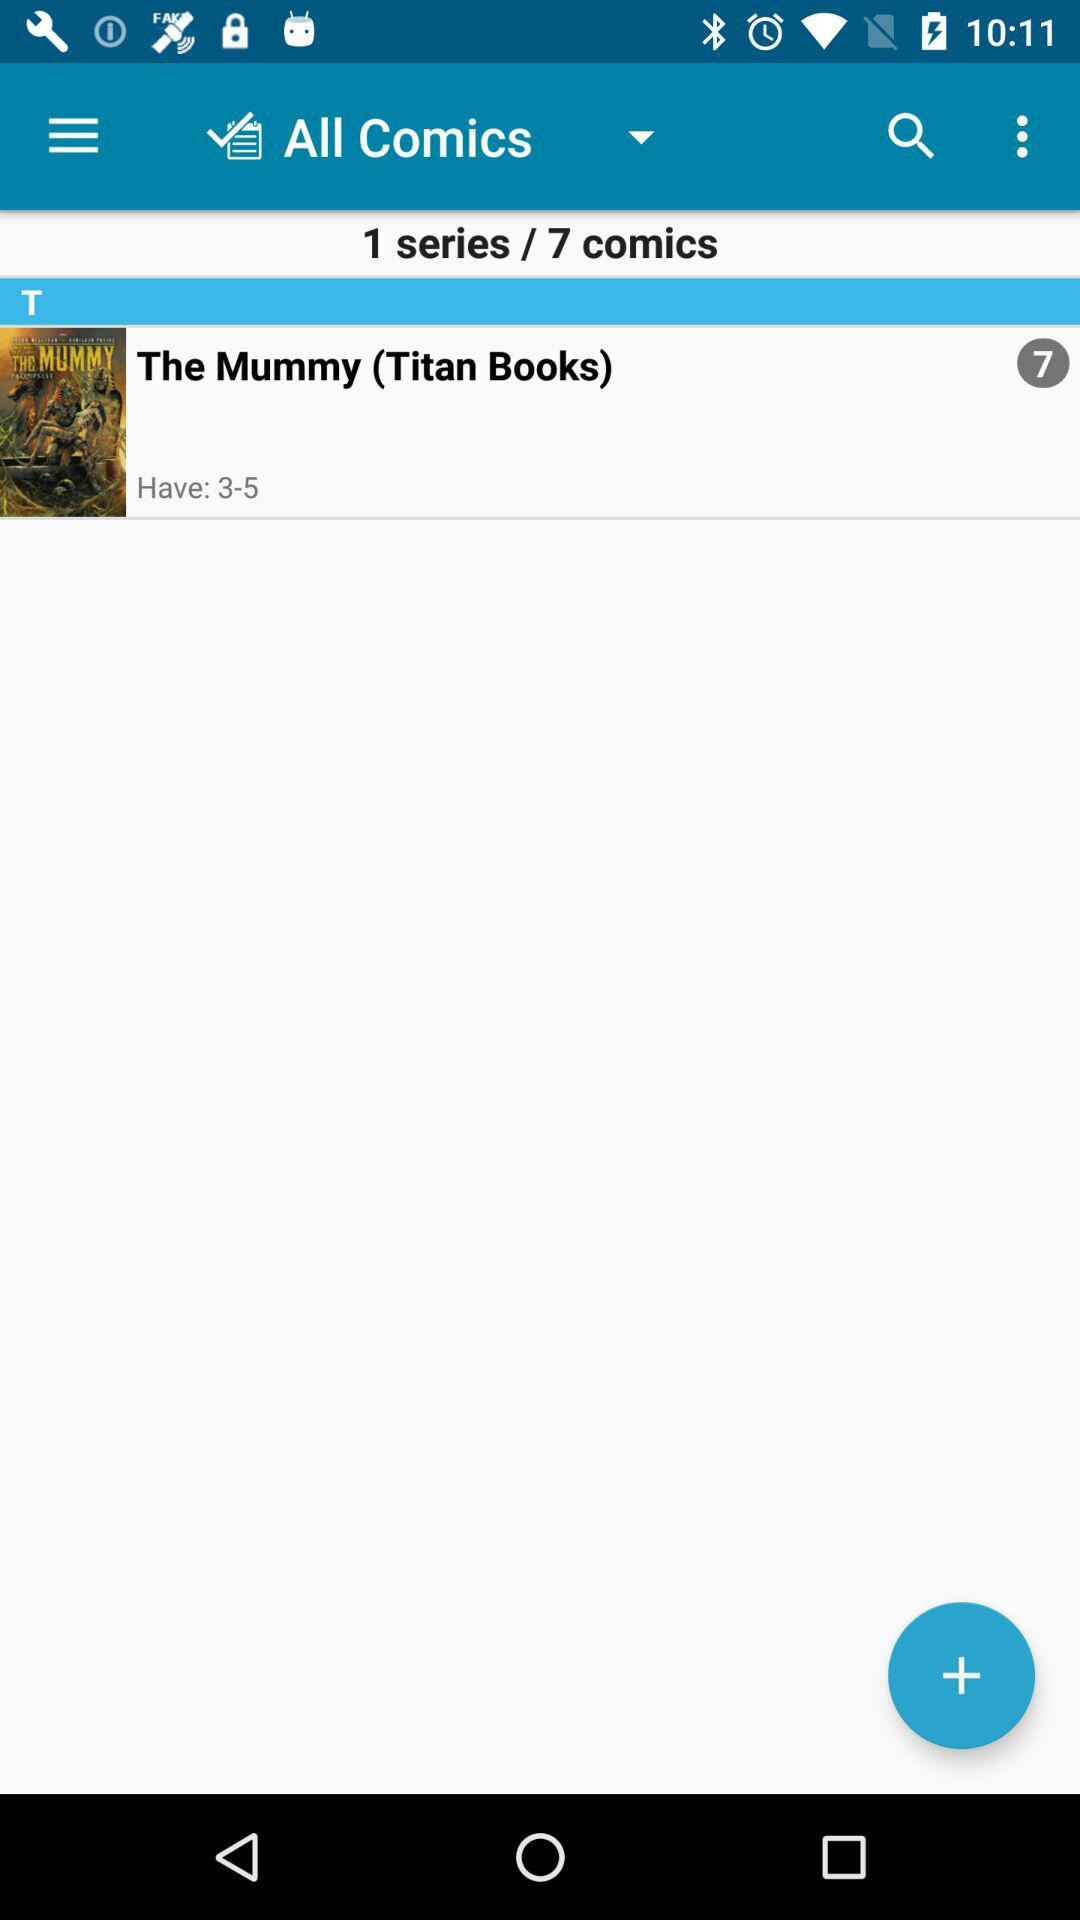What is the rating of book?
When the provided information is insufficient, respond with <no answer>. <no answer> 